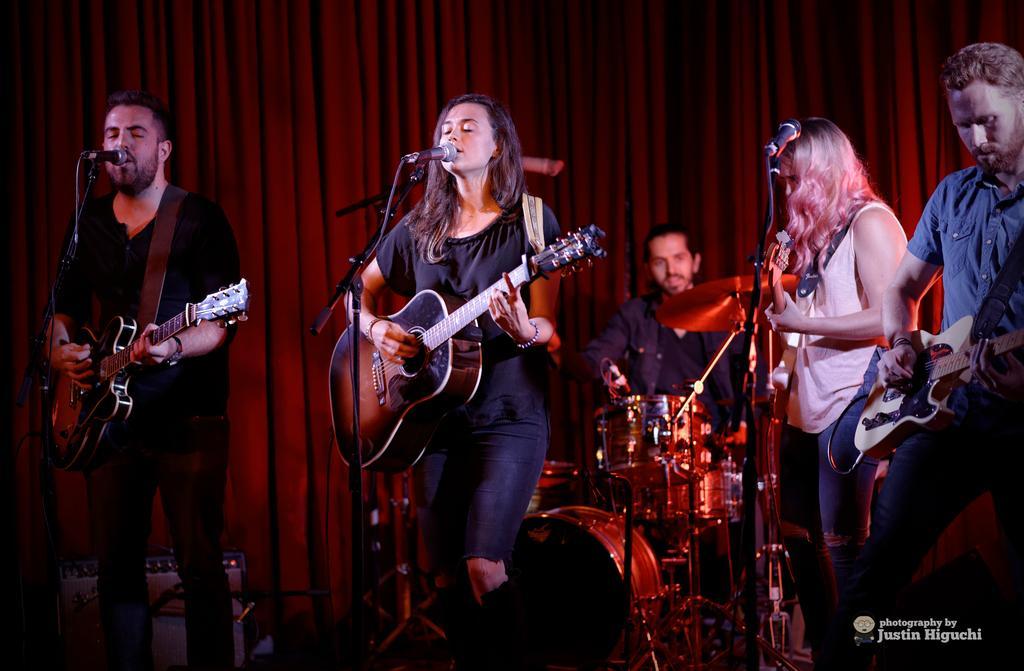Describe this image in one or two sentences. Here we can see a five people who are performing on a stage on a musical event. They are playing a guitar and singing on a microphone. 